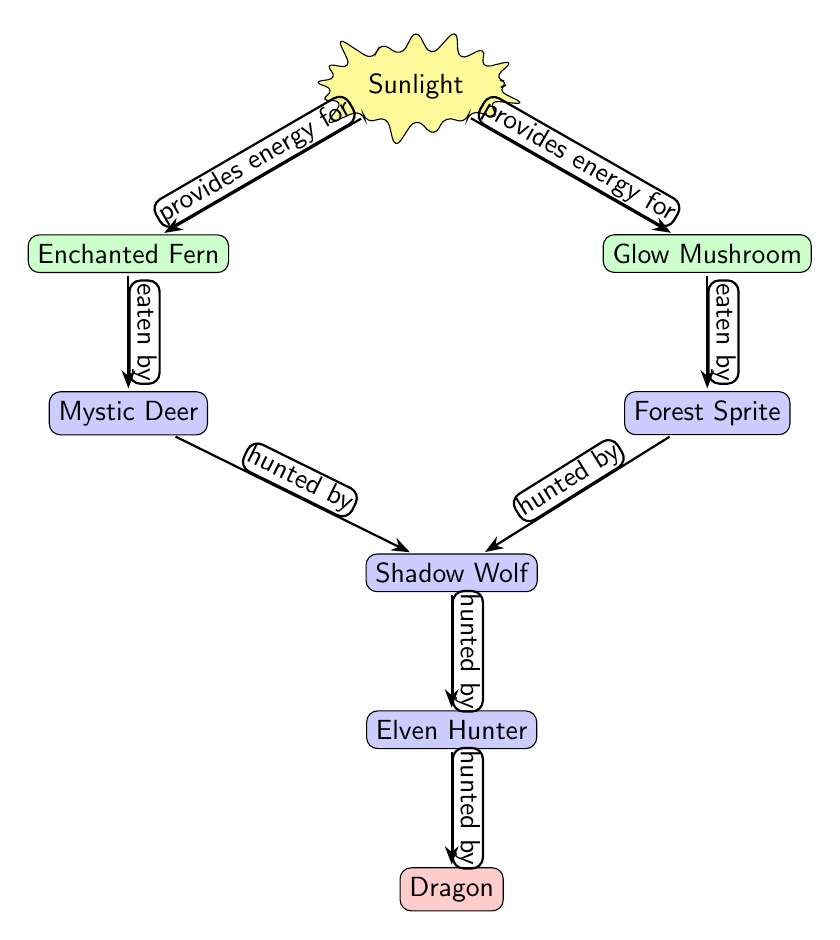What is the topmost node in the diagram? The topmost node in the diagram is the "Sunlight" node, which represents the source of energy for the ecosystem.
Answer: Sunlight How many consumer nodes are there? There are four consumer nodes in the diagram: "Mystic Deer," "Forest Sprite," "Shadow Wolf," and "Elven Hunter." This is determined by counting all nodes that are filled with the blue color, indicating consumers.
Answer: 4 Which producer is eaten by the "Mystic Deer"? The "Enchanted Fern" is the producer that is specifically noted to be eaten by the "Mystic Deer," as indicated by the arrow pointing from "Fern" to "Deer."
Answer: Enchanted Fern Who is the apex predator in this ecosystem? The apex predator in this ecosystem is represented by the "Dragon," which is at the bottom of the food chain diagram and is the last node to receive a hunting relationship.
Answer: Dragon What type of relationship exists between "Wolf" and "Hunter"? The relationship between "Wolf" and "Hunter" is a predation relationship, as indicated by the arrow labeled "hunted by" pointing from "Wolf" to "Hunter."
Answer: hunted by Which producer provides energy for the "Glow Mushroom"? The "Sunlight" node provides energy for the "Glow Mushroom," as indicated by the arrow pointing from "Sunlight" to "Glow Mushroom."
Answer: Sunlight How many edges are in the diagram representing predatory relationships? There are six edges representing predatory relationships in the diagram. This is found by counting all arrows that indicate eating or hunting relationships.
Answer: 6 What are the two producers in the ecosystem? The two producers in the ecosystem are the "Enchanted Fern" and "Glow Mushroom," both of which receive energy from "Sunlight."
Answer: Enchanted Fern, Glow Mushroom Which creature is hunted by both "Shadow Wolf" and "Hunter"? The "Mystic Deer" is hunted by the "Shadow Wolf," and the "Forest Sprite" is also hunted by the "Shadow Wolf," while the "Hunter" solely hunts the "Wolf." This shows that there isn't a shared hunted prey in this dynamic.
Answer: None 